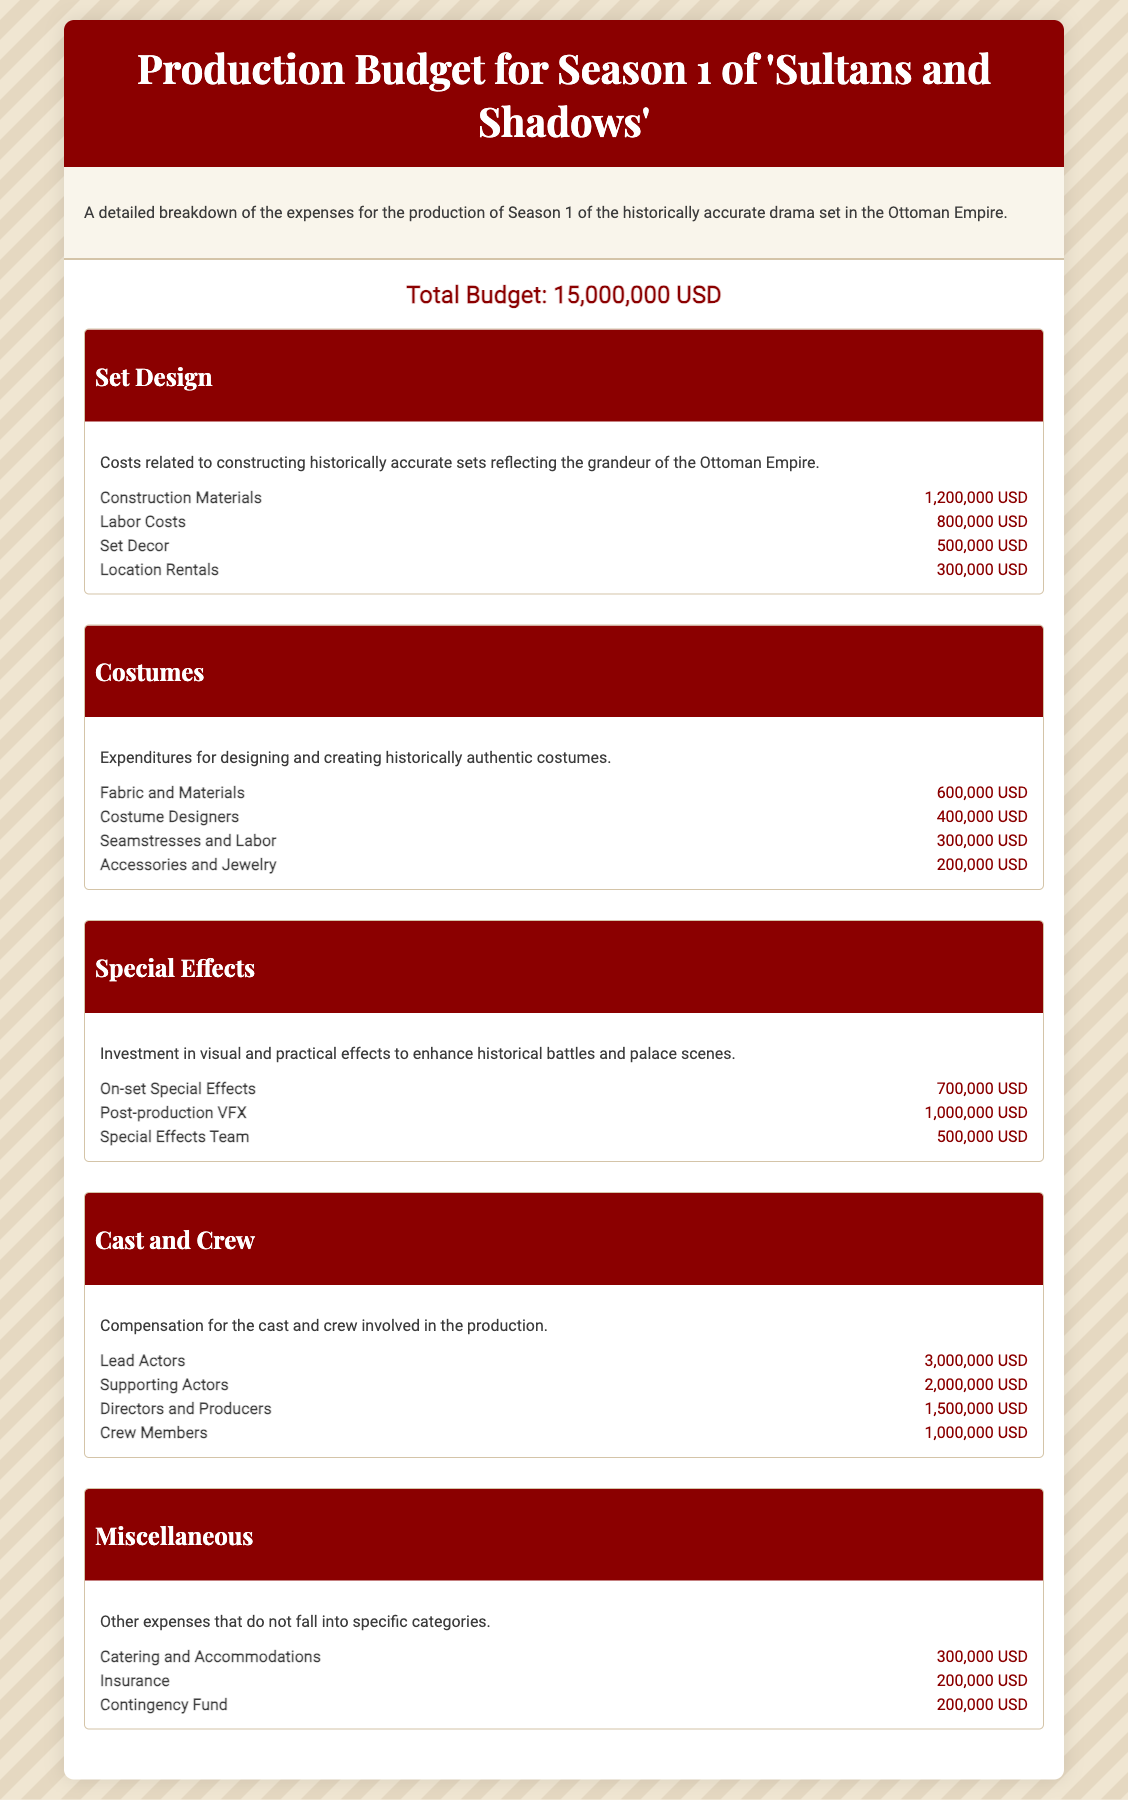What is the total budget? The total budget is stated prominently at the beginning of the budget breakdown section of the document.
Answer: 15,000,000 USD How much is allocated for set decor? The amount for set decor is listed under the Set Design category in the budget breakdown section.
Answer: 500,000 USD What is the cost for Lead Actors? The cost for Lead Actors is found in the Cast and Crew category.
Answer: 3,000,000 USD What are the total costs for Special Effects? The total costs can be calculated by summing the line items under the Special Effects category.
Answer: 2,200,000 USD How much is budgeted for costume designers? This information is specified in the Costumes category under the line item for Costume Designers.
Answer: 400,000 USD What is included in the Miscellaneous category? The Miscellaneous category lists various expenses not specified elsewhere, such as Catering and Accommodations, Insurance, and Contingency Fund.
Answer: Catering and Accommodations, Insurance, Contingency Fund Which category has the highest expenditure? The comparison of categories will show that the Cast and Crew category has the highest total cost.
Answer: Cast and Crew How much is spent on fabric and materials for costumes? The budget allocation for fabric and materials is included in the Costumes section and consists of a specific line item.
Answer: 600,000 USD How many line items are listed under Set Design? The Set Design category includes multiple specific line items, indicating various types of related expenses.
Answer: 4 